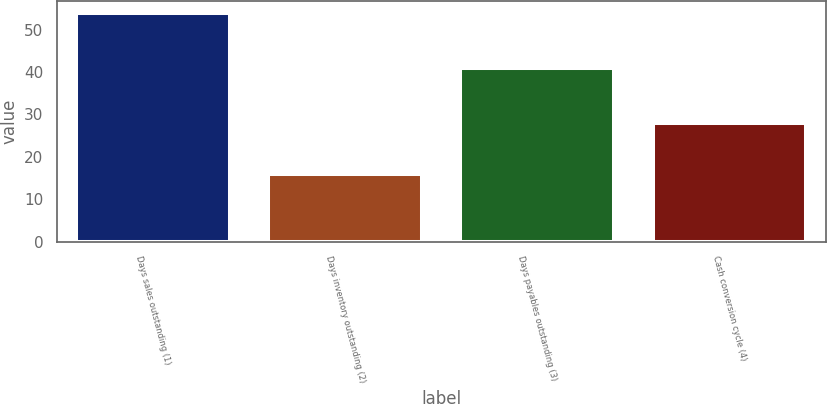<chart> <loc_0><loc_0><loc_500><loc_500><bar_chart><fcel>Days sales outstanding (1)<fcel>Days inventory outstanding (2)<fcel>Days payables outstanding (3)<fcel>Cash conversion cycle (4)<nl><fcel>54<fcel>16<fcel>41<fcel>28<nl></chart> 